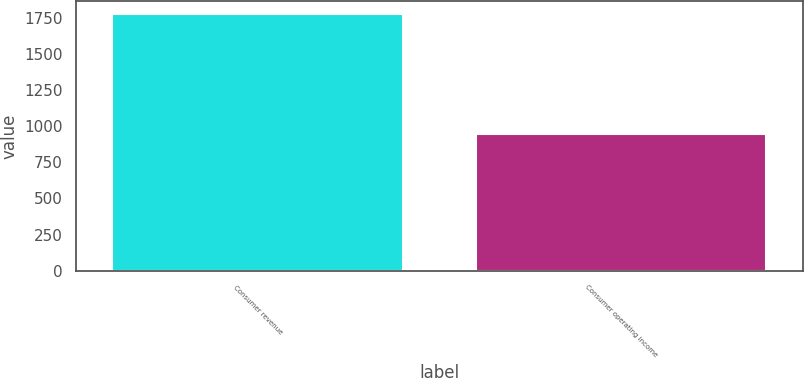<chart> <loc_0><loc_0><loc_500><loc_500><bar_chart><fcel>Consumer revenue<fcel>Consumer operating income<nl><fcel>1773<fcel>948<nl></chart> 